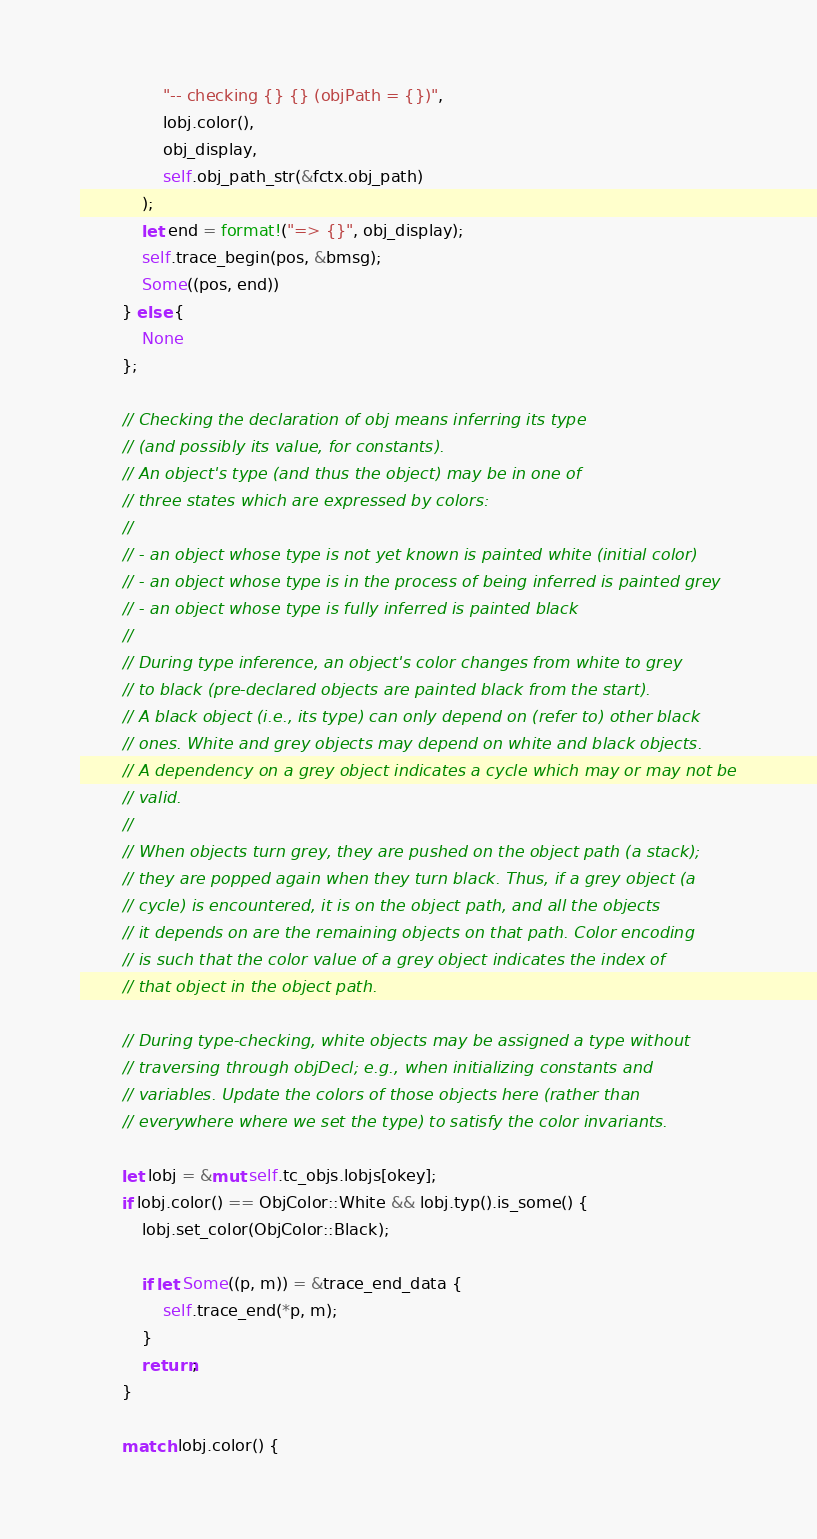Convert code to text. <code><loc_0><loc_0><loc_500><loc_500><_Rust_>                "-- checking {} {} (objPath = {})",
                lobj.color(),
                obj_display,
                self.obj_path_str(&fctx.obj_path)
            );
            let end = format!("=> {}", obj_display);
            self.trace_begin(pos, &bmsg);
            Some((pos, end))
        } else {
            None
        };

        // Checking the declaration of obj means inferring its type
        // (and possibly its value, for constants).
        // An object's type (and thus the object) may be in one of
        // three states which are expressed by colors:
        //
        // - an object whose type is not yet known is painted white (initial color)
        // - an object whose type is in the process of being inferred is painted grey
        // - an object whose type is fully inferred is painted black
        //
        // During type inference, an object's color changes from white to grey
        // to black (pre-declared objects are painted black from the start).
        // A black object (i.e., its type) can only depend on (refer to) other black
        // ones. White and grey objects may depend on white and black objects.
        // A dependency on a grey object indicates a cycle which may or may not be
        // valid.
        //
        // When objects turn grey, they are pushed on the object path (a stack);
        // they are popped again when they turn black. Thus, if a grey object (a
        // cycle) is encountered, it is on the object path, and all the objects
        // it depends on are the remaining objects on that path. Color encoding
        // is such that the color value of a grey object indicates the index of
        // that object in the object path.

        // During type-checking, white objects may be assigned a type without
        // traversing through objDecl; e.g., when initializing constants and
        // variables. Update the colors of those objects here (rather than
        // everywhere where we set the type) to satisfy the color invariants.

        let lobj = &mut self.tc_objs.lobjs[okey];
        if lobj.color() == ObjColor::White && lobj.typ().is_some() {
            lobj.set_color(ObjColor::Black);

            if let Some((p, m)) = &trace_end_data {
                self.trace_end(*p, m);
            }
            return;
        }

        match lobj.color() {</code> 